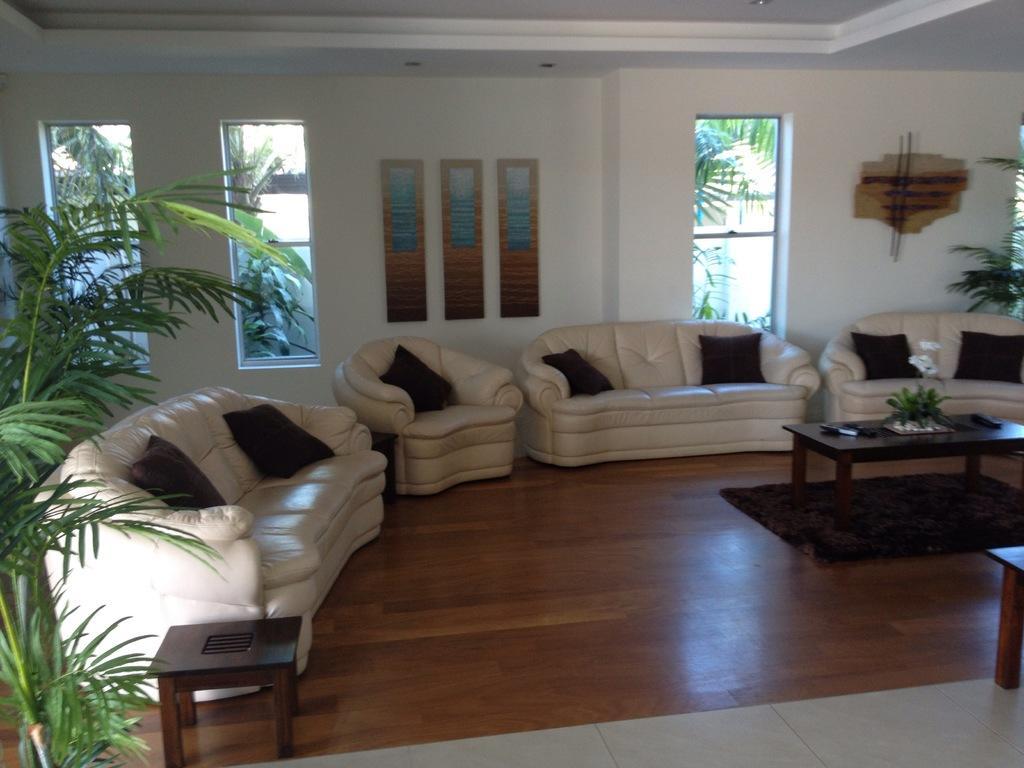In one or two sentences, can you explain what this image depicts? As we can see in the image there is a white color wall, window, trees, sofas and pillows and on the right side there is a table. 